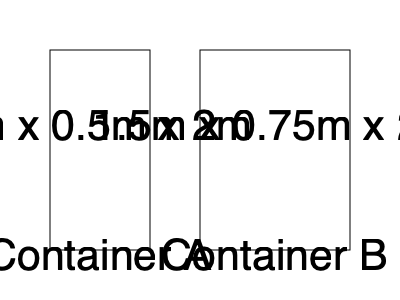You need to store various sports equipment for an upcoming community event. Two storage containers are available: Container A (1m x 0.5m x 2m) and Container B (1.5m x 0.75m x 2m). How many times larger is the volume of Container B compared to Container A? To solve this problem, we need to calculate the volumes of both containers and then compare them:

1. Calculate the volume of Container A:
   $V_A = 1m \times 0.5m \times 2m = 1 m^3$

2. Calculate the volume of Container B:
   $V_B = 1.5m \times 0.75m \times 2m = 2.25 m^3$

3. Compare the volumes by dividing B by A:
   $\frac{V_B}{V_A} = \frac{2.25 m^3}{1 m^3} = 2.25$

Therefore, Container B is 2.25 times larger than Container A.
Answer: 2.25 times 